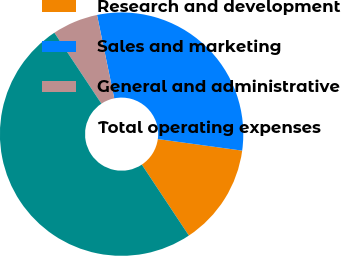<chart> <loc_0><loc_0><loc_500><loc_500><pie_chart><fcel>Research and development<fcel>Sales and marketing<fcel>General and administrative<fcel>Total operating expenses<nl><fcel>13.52%<fcel>30.4%<fcel>6.08%<fcel>50.0%<nl></chart> 